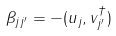<formula> <loc_0><loc_0><loc_500><loc_500>\beta _ { j j ^ { \prime } } = - ( u _ { j } , v ^ { \dag } _ { j ^ { \prime } } )</formula> 